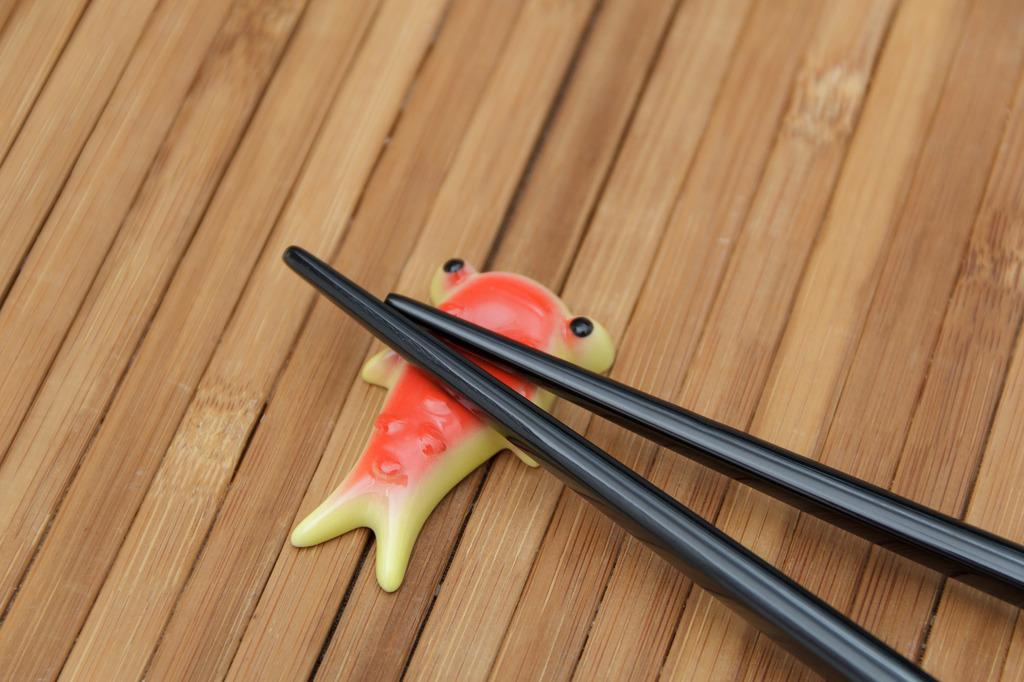What objects can be seen in the image? There are two sticks and a toy-like object in the image. How are the sticks positioned in the image? The sticks are placed on a toy-like object. What type of surface is the toy-like object resting on? The toy-like object is on a wooden floor. What type of shoes are visible in the image? There are no shoes present in the image. What material is the steel object made of in the image? There is no steel object present in the image. 